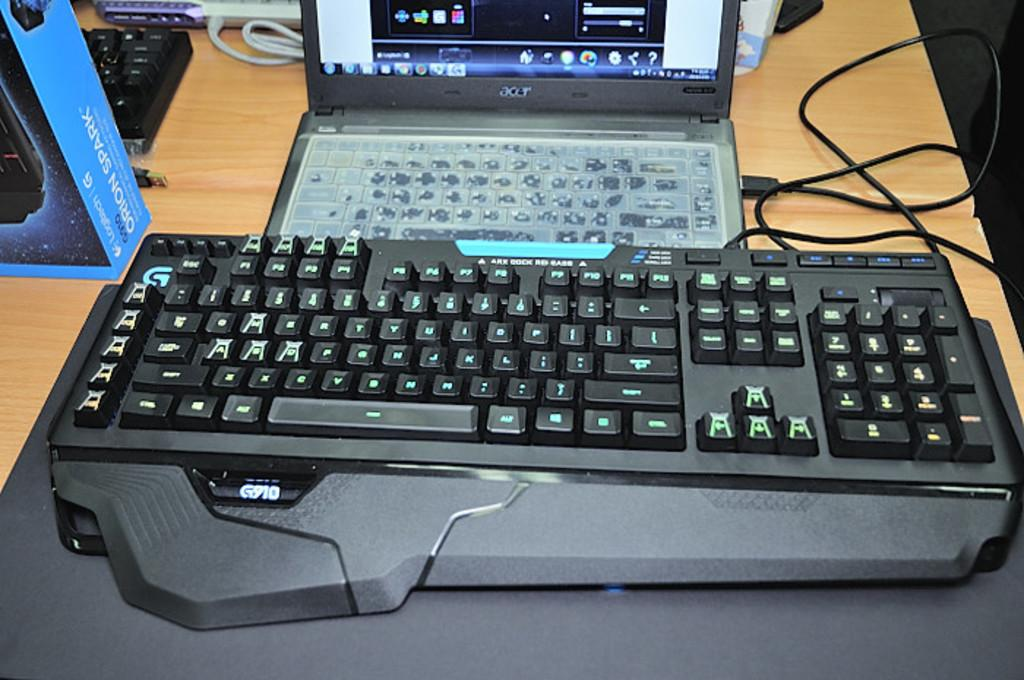<image>
Render a clear and concise summary of the photo. An ACER laptop sits behind a black G910 keyboard 